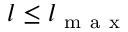Convert formula to latex. <formula><loc_0><loc_0><loc_500><loc_500>l \leq l _ { m a x }</formula> 